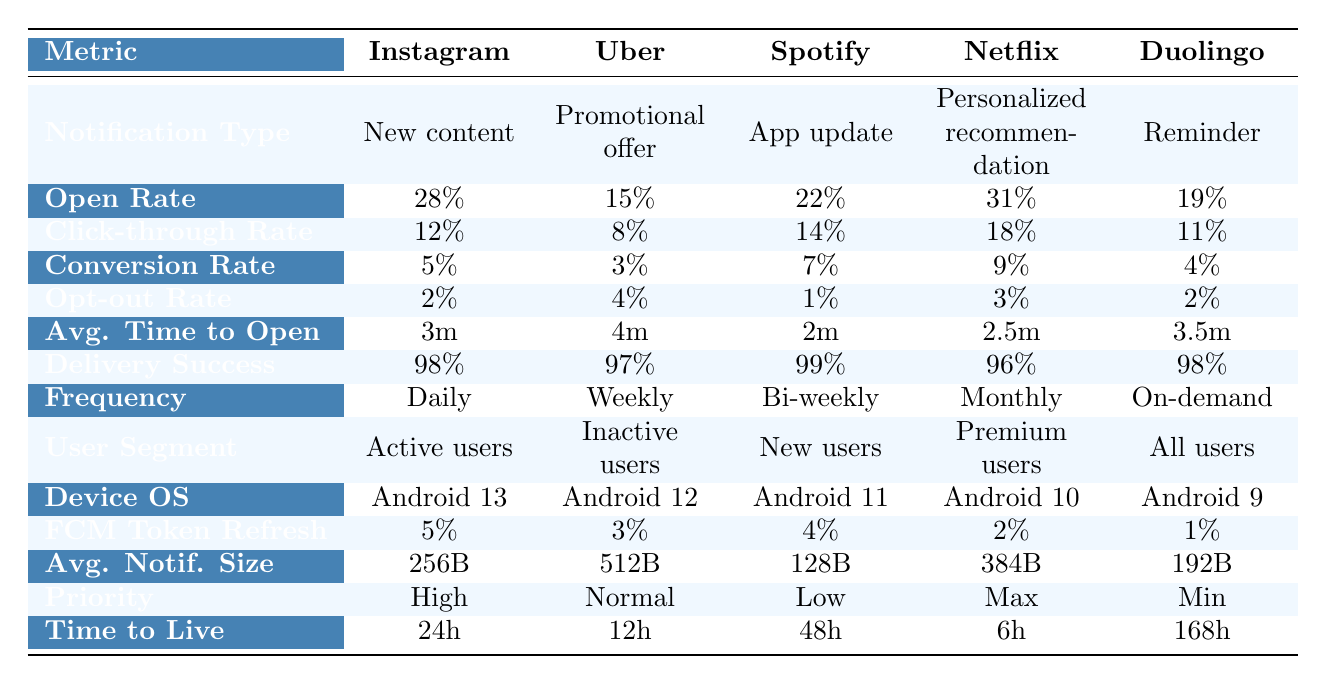What is the open rate for Netflix? The table indicates that the open rate for Netflix is 31%.
Answer: 31% What is the click-through rate for Uber? According to the table, the click-through rate for Uber is 8%.
Answer: 8% Which app has the highest conversion rate? By comparing the conversion rates in the table, Netflix has the highest conversion rate at 9%.
Answer: Netflix Is the opt-out rate for Spotify lower than for Duolingo? The opt-out rate for Spotify is 1%, while for Duolingo it is 2%. Since 1% is less than 2%, the statement is true.
Answer: Yes What is the average time to open a notification for Duolingo? The average time to open a notification for Duolingo is listed as 3.5 minutes in the table.
Answer: 3.5 minutes Which notification type does Spotify use? The notification type for Spotify as per the table is "App update."
Answer: App update What is the delivery success rate for Uber? The delivery success rate for Uber is 97% according to the provided data.
Answer: 97% What is the average open rate across all apps? To calculate the average open rate, add the open rates: 0.28 + 0.15 + 0.22 + 0.31 + 0.19 = 1.15, then divide by 5 (the number of apps) to get 1.15/5 = 0.23 or 23%.
Answer: 23% Which app has the least average notification size? By reviewing the average notification sizes, Spotify has the least at 128 bytes.
Answer: Spotify Is the notification frequency for Instagram daily? According to the table, Instagram's notification frequency is indeed listed as daily.
Answer: Yes Which app has the highest delivery success rate? The delivery success rates are 98% for Instagram and Duolingo, and 99% for Spotify, so Spotify has the highest delivery success rate.
Answer: Spotify What is the difference in the opt-out rate between Uber and Spotify? The opt-out rate for Uber is 4% and for Spotify it is 1%, so the difference is 4% - 1% = 3%.
Answer: 3% Among the apps, which is primarily targeted at active users? The table shows that Instagram is primarily targeted at active users.
Answer: Instagram How many apps have a notification priority of "High"? The only app with a notification priority of "High" is Instagram, as mentioned in the table.
Answer: 1 What is the time to live for notifications from Duolingo? From the table, Duolingo has a time to live for notifications of 168 hours.
Answer: 168 hours 